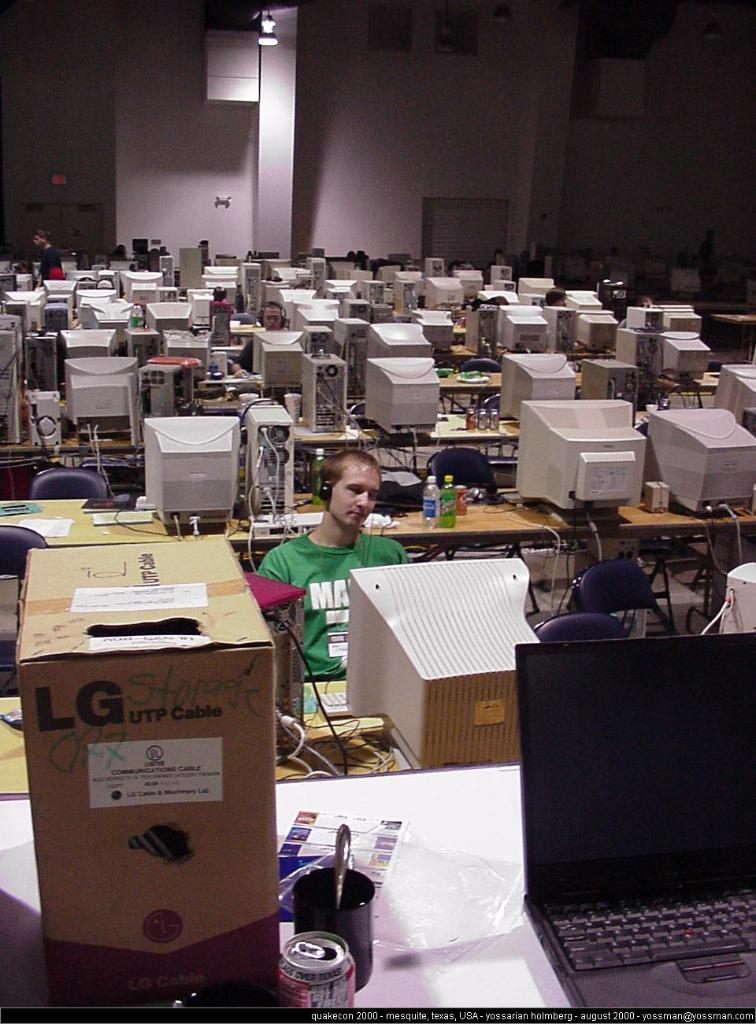<image>
Write a terse but informative summary of the picture. A man sits at an old computer monitor next to a LG UTP Cable box. 